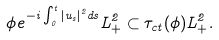Convert formula to latex. <formula><loc_0><loc_0><loc_500><loc_500>\phi e ^ { - i \int _ { 0 } ^ { t } | u _ { s } | ^ { 2 } d s } L ^ { 2 } _ { + } \subset \tau _ { c t } ( \phi ) L ^ { 2 } _ { + } .</formula> 